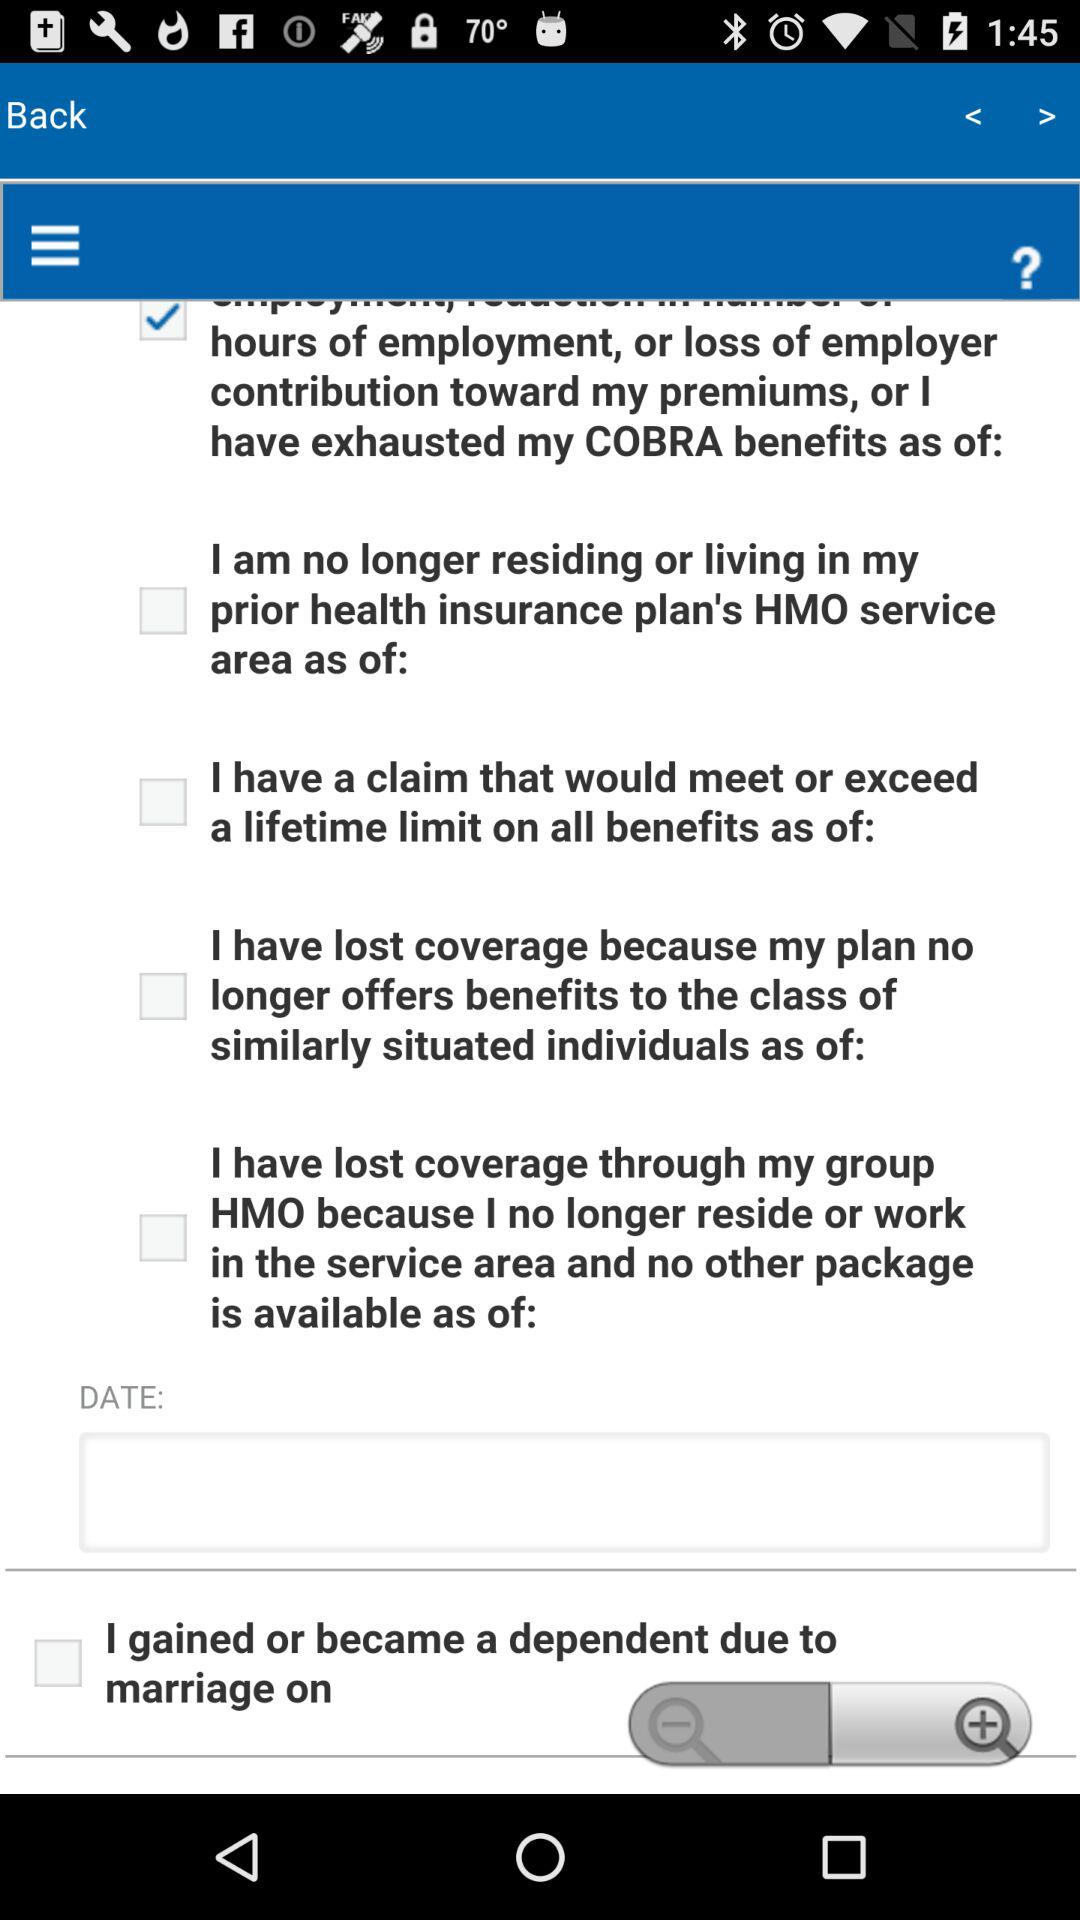What is the selected option?
When the provided information is insufficient, respond with <no answer>. <no answer> 